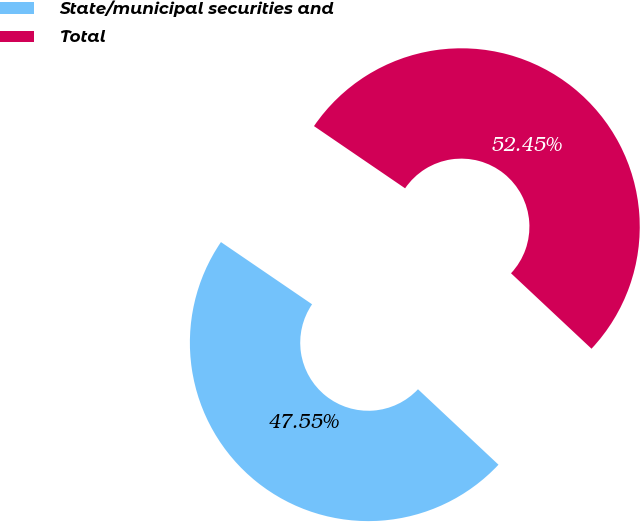<chart> <loc_0><loc_0><loc_500><loc_500><pie_chart><fcel>State/municipal securities and<fcel>Total<nl><fcel>47.55%<fcel>52.45%<nl></chart> 